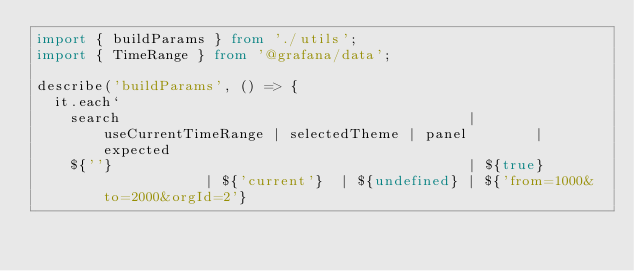<code> <loc_0><loc_0><loc_500><loc_500><_TypeScript_>import { buildParams } from './utils';
import { TimeRange } from '@grafana/data';

describe('buildParams', () => {
  it.each`
    search                                         | useCurrentTimeRange | selectedTheme | panel        | expected
    ${''}                                          | ${true}             | ${'current'}  | ${undefined} | ${'from=1000&to=2000&orgId=2'}</code> 